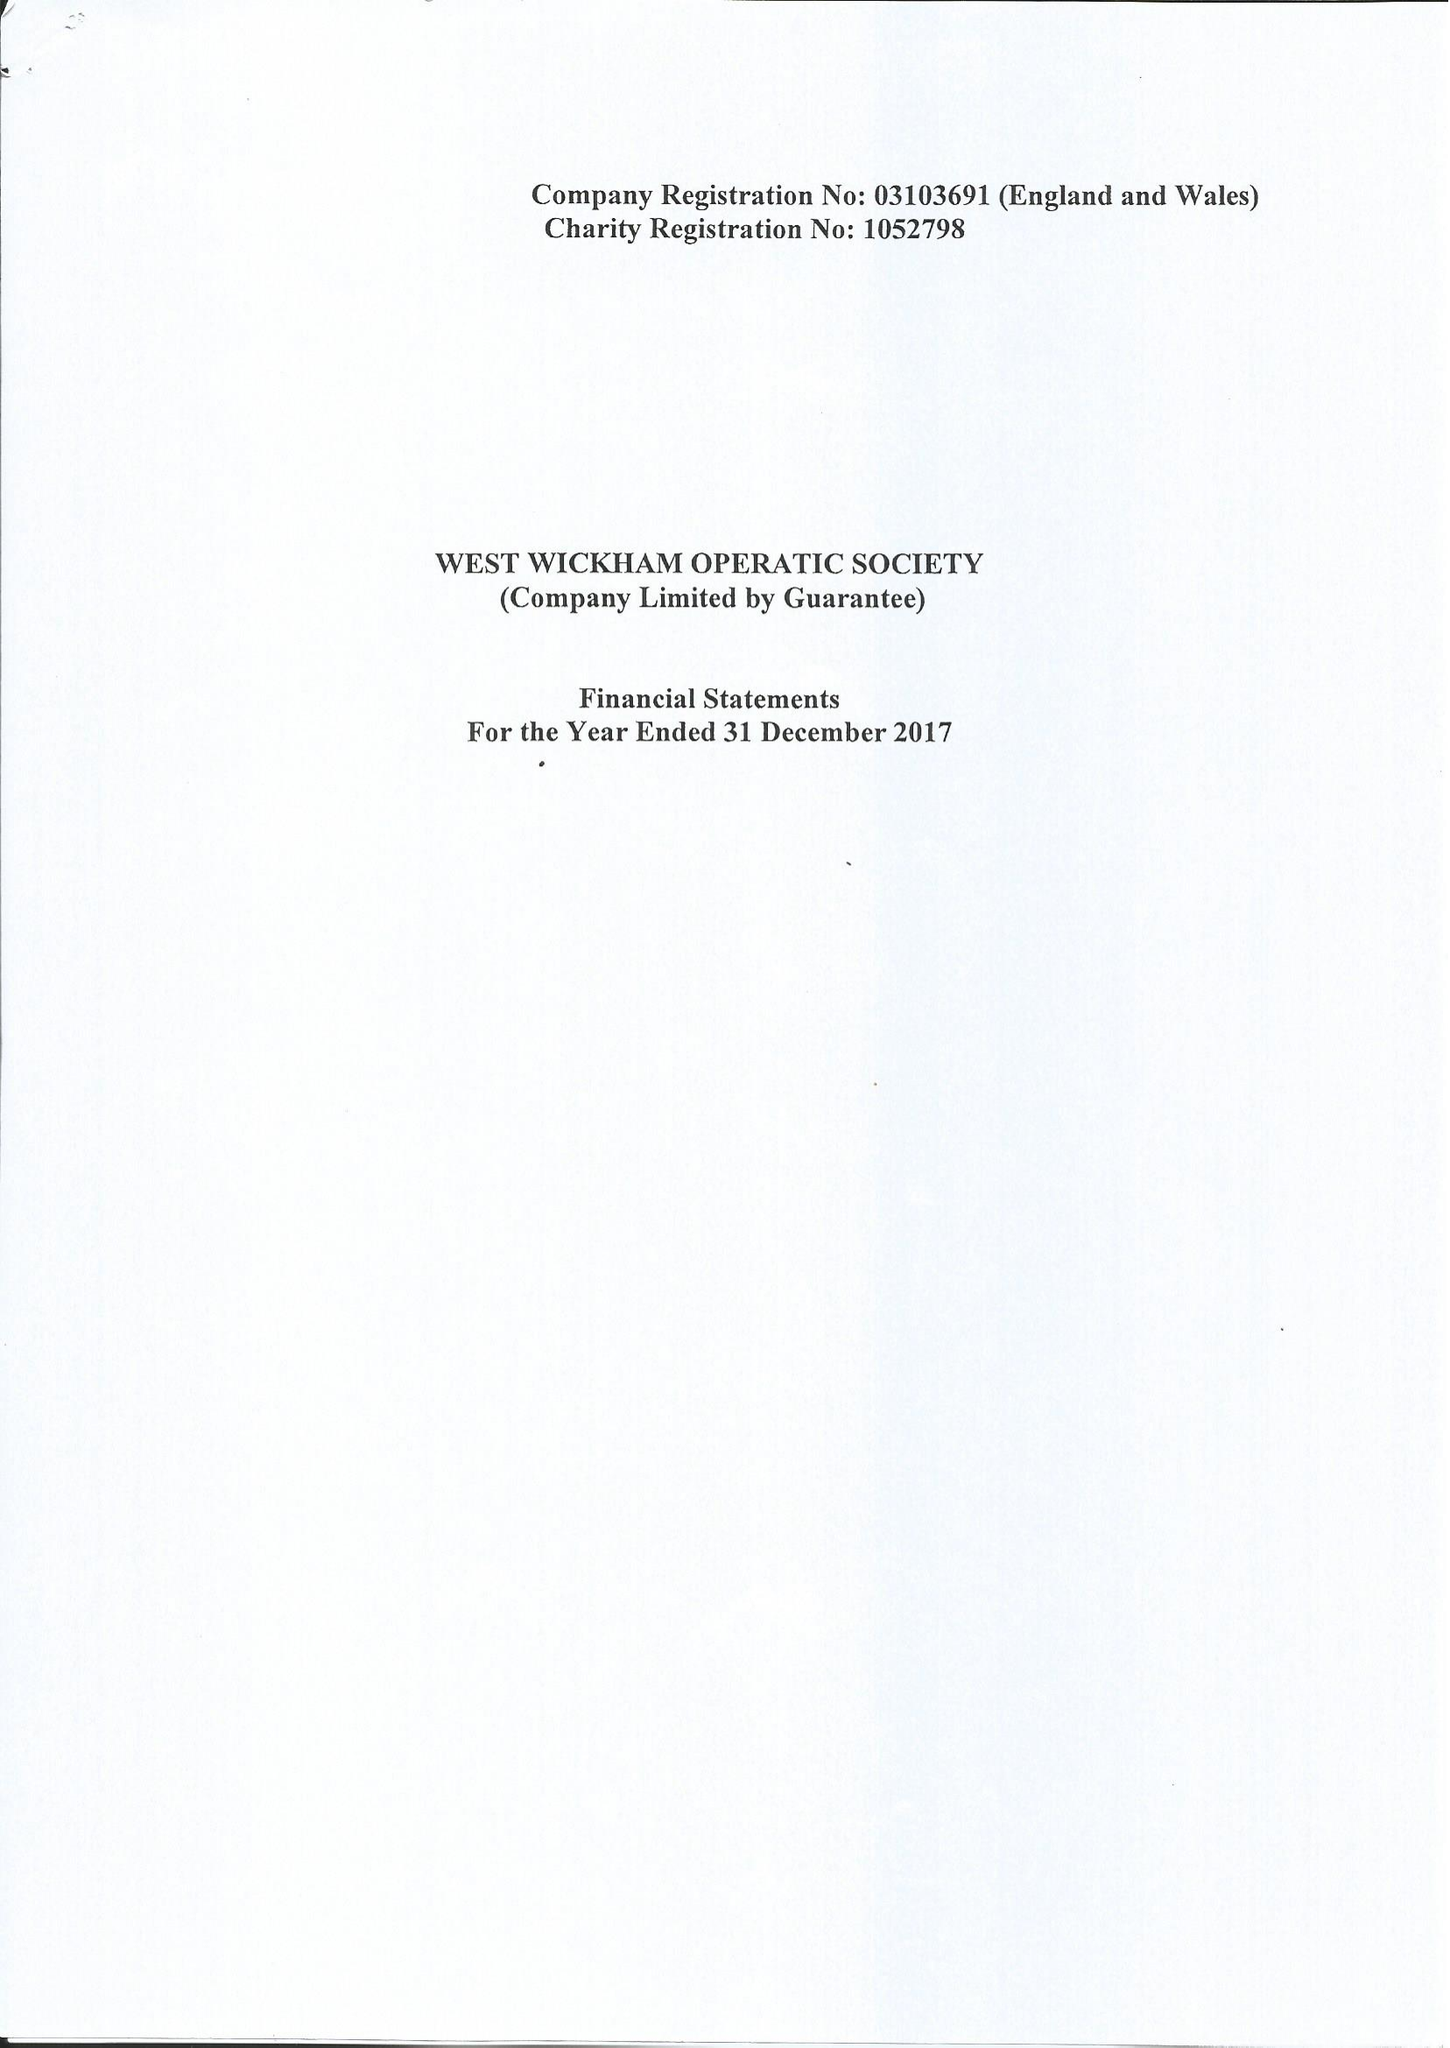What is the value for the address__post_town?
Answer the question using a single word or phrase. BECKENHAM 